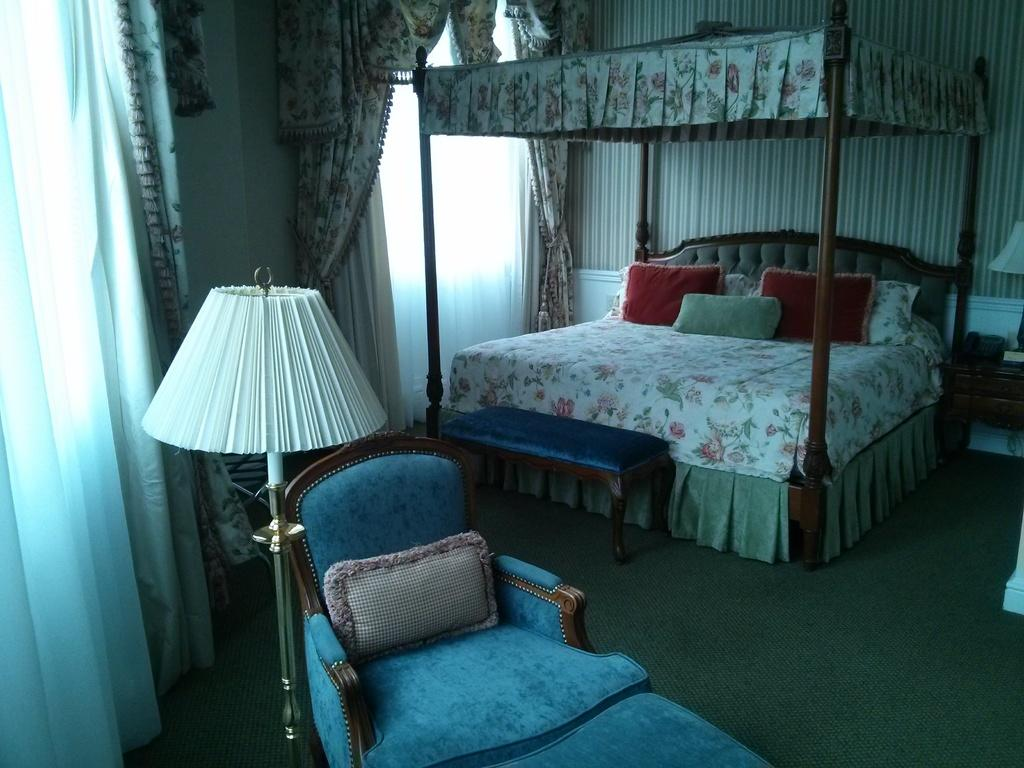What type of space is depicted in the image? The image is an inner view of a room. What type of furniture is present in the room? There is a bed and a chair in the room. What type of lighting is present in the room? There is a lamp in the room. What type of window treatment is present in the room? There are curtains on the windows in the room. What type of instrument is being played in the room in the image? There is no instrument present in the image, and therefore no such activity can be observed. What type of pest can be seen crawling on the bed in the image? There is no pest present in the image, and therefore no such creature can be observed. 